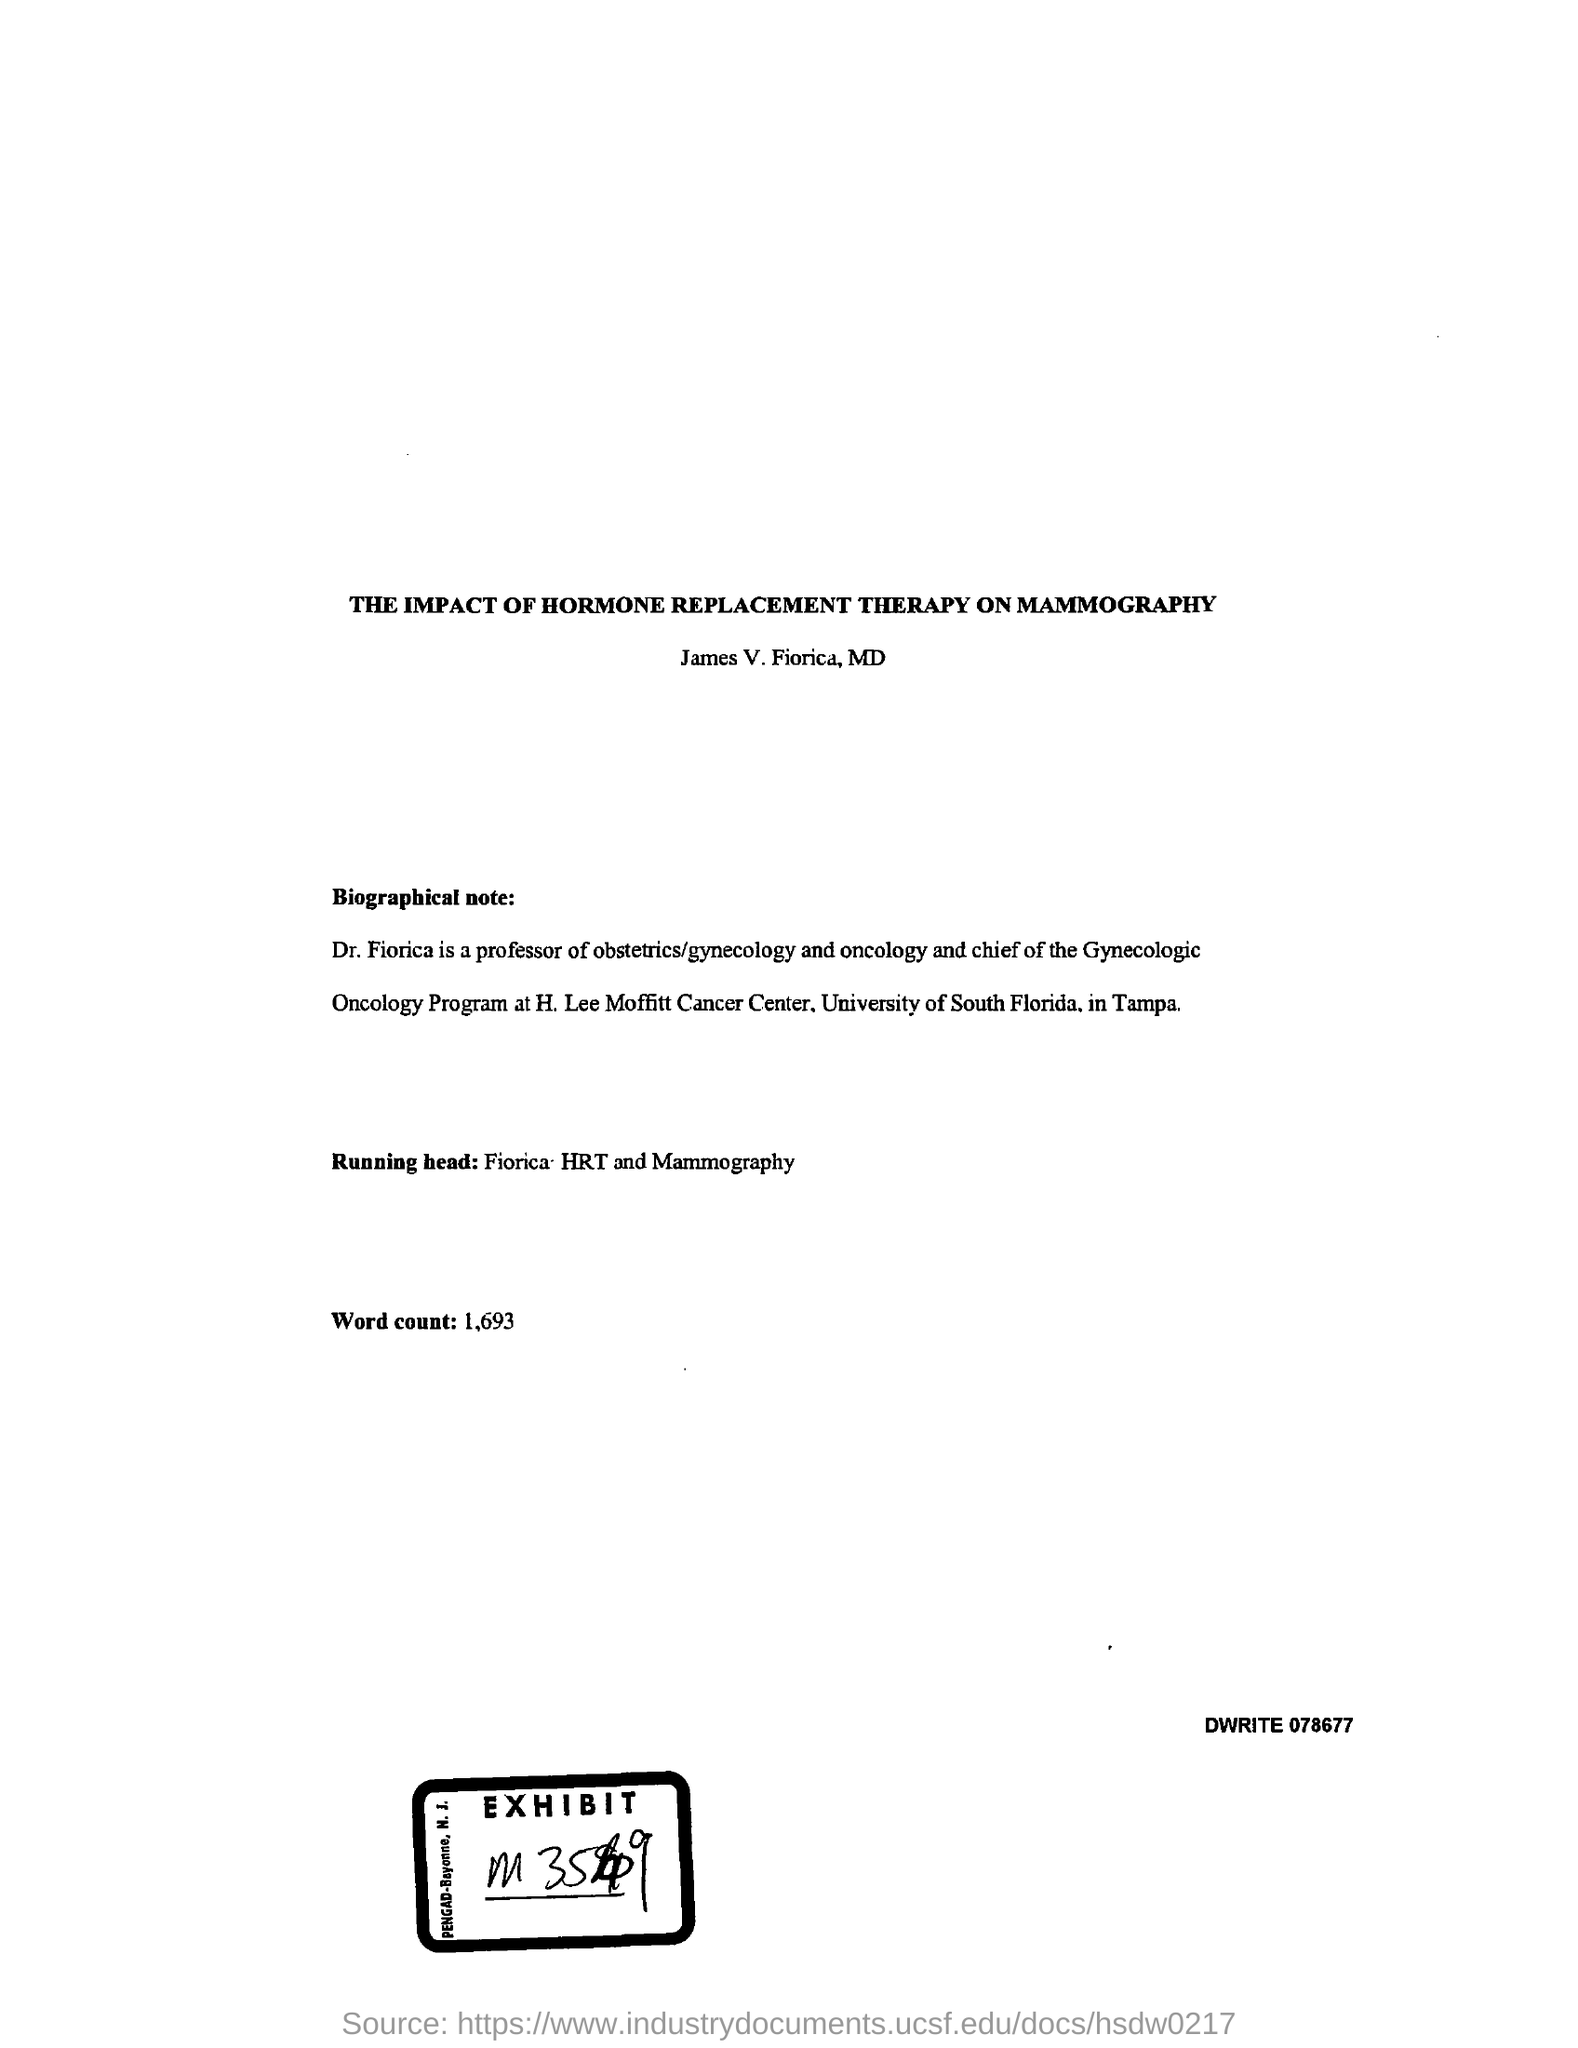What is the running head?
Offer a very short reply. Fiorica hrt and mammography. What is the word count?
Ensure brevity in your answer.  1,693. 